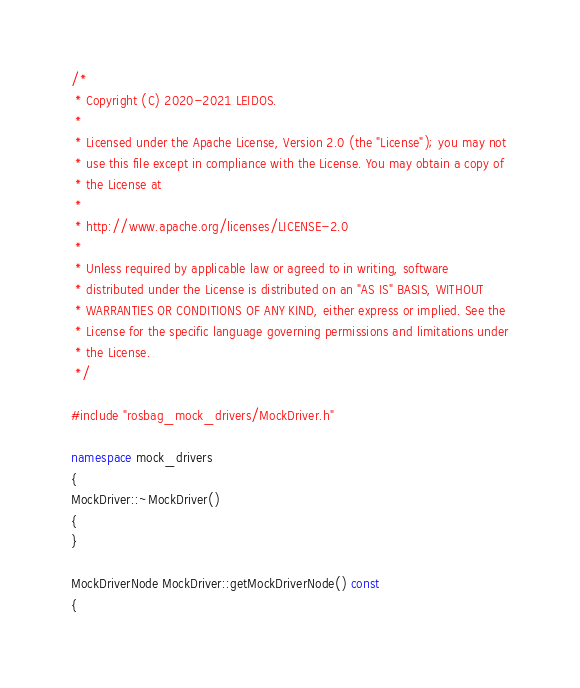Convert code to text. <code><loc_0><loc_0><loc_500><loc_500><_C++_>/*
 * Copyright (C) 2020-2021 LEIDOS.
 *
 * Licensed under the Apache License, Version 2.0 (the "License"); you may not
 * use this file except in compliance with the License. You may obtain a copy of
 * the License at
 *
 * http://www.apache.org/licenses/LICENSE-2.0
 *
 * Unless required by applicable law or agreed to in writing, software
 * distributed under the License is distributed on an "AS IS" BASIS, WITHOUT
 * WARRANTIES OR CONDITIONS OF ANY KIND, either express or implied. See the
 * License for the specific language governing permissions and limitations under
 * the License.
 */

#include "rosbag_mock_drivers/MockDriver.h"

namespace mock_drivers
{
MockDriver::~MockDriver()
{
}

MockDriverNode MockDriver::getMockDriverNode() const
{</code> 